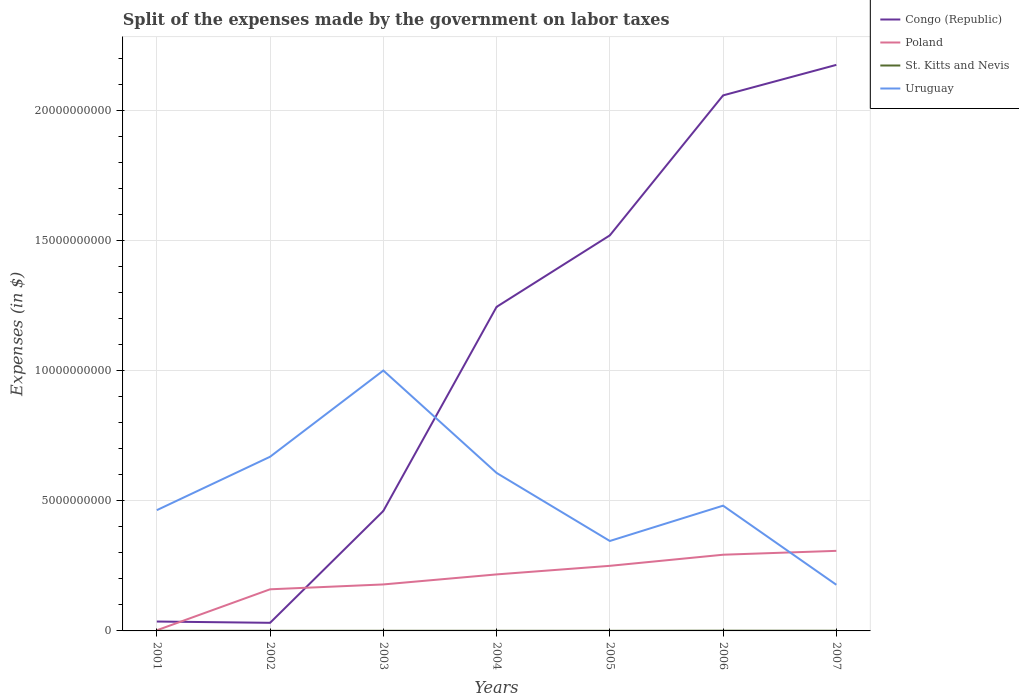How many different coloured lines are there?
Ensure brevity in your answer.  4. Does the line corresponding to Congo (Republic) intersect with the line corresponding to Uruguay?
Your response must be concise. Yes. Is the number of lines equal to the number of legend labels?
Offer a very short reply. Yes. Across all years, what is the maximum expenses made by the government on labor taxes in Congo (Republic)?
Your response must be concise. 3.12e+08. What is the total expenses made by the government on labor taxes in Poland in the graph?
Your response must be concise. -9.06e+08. What is the difference between the highest and the second highest expenses made by the government on labor taxes in Poland?
Ensure brevity in your answer.  3.06e+09. How many lines are there?
Keep it short and to the point. 4. How many years are there in the graph?
Provide a succinct answer. 7. Where does the legend appear in the graph?
Offer a very short reply. Top right. What is the title of the graph?
Your answer should be very brief. Split of the expenses made by the government on labor taxes. What is the label or title of the Y-axis?
Offer a terse response. Expenses (in $). What is the Expenses (in $) of Congo (Republic) in 2001?
Provide a short and direct response. 3.61e+08. What is the Expenses (in $) in Poland in 2001?
Make the answer very short. 2.50e+07. What is the Expenses (in $) in St. Kitts and Nevis in 2001?
Offer a very short reply. 4.40e+06. What is the Expenses (in $) of Uruguay in 2001?
Your answer should be compact. 4.65e+09. What is the Expenses (in $) of Congo (Republic) in 2002?
Give a very brief answer. 3.12e+08. What is the Expenses (in $) of Poland in 2002?
Ensure brevity in your answer.  1.60e+09. What is the Expenses (in $) in St. Kitts and Nevis in 2002?
Provide a succinct answer. 4.50e+06. What is the Expenses (in $) in Uruguay in 2002?
Your answer should be compact. 6.70e+09. What is the Expenses (in $) of Congo (Republic) in 2003?
Give a very brief answer. 4.61e+09. What is the Expenses (in $) in Poland in 2003?
Provide a succinct answer. 1.79e+09. What is the Expenses (in $) in St. Kitts and Nevis in 2003?
Give a very brief answer. 5.20e+06. What is the Expenses (in $) of Uruguay in 2003?
Provide a succinct answer. 1.00e+1. What is the Expenses (in $) of Congo (Republic) in 2004?
Your answer should be very brief. 1.25e+1. What is the Expenses (in $) in Poland in 2004?
Your answer should be compact. 2.17e+09. What is the Expenses (in $) of St. Kitts and Nevis in 2004?
Give a very brief answer. 5.10e+06. What is the Expenses (in $) of Uruguay in 2004?
Provide a short and direct response. 6.08e+09. What is the Expenses (in $) of Congo (Republic) in 2005?
Your answer should be compact. 1.52e+1. What is the Expenses (in $) of Poland in 2005?
Make the answer very short. 2.50e+09. What is the Expenses (in $) of Uruguay in 2005?
Keep it short and to the point. 3.46e+09. What is the Expenses (in $) in Congo (Republic) in 2006?
Give a very brief answer. 2.06e+1. What is the Expenses (in $) in Poland in 2006?
Keep it short and to the point. 2.93e+09. What is the Expenses (in $) in St. Kitts and Nevis in 2006?
Your answer should be compact. 8.70e+06. What is the Expenses (in $) in Uruguay in 2006?
Offer a terse response. 4.82e+09. What is the Expenses (in $) of Congo (Republic) in 2007?
Offer a terse response. 2.18e+1. What is the Expenses (in $) in Poland in 2007?
Provide a succinct answer. 3.08e+09. What is the Expenses (in $) of St. Kitts and Nevis in 2007?
Give a very brief answer. 7.40e+06. What is the Expenses (in $) in Uruguay in 2007?
Your answer should be very brief. 1.77e+09. Across all years, what is the maximum Expenses (in $) in Congo (Republic)?
Your answer should be compact. 2.18e+1. Across all years, what is the maximum Expenses (in $) of Poland?
Give a very brief answer. 3.08e+09. Across all years, what is the maximum Expenses (in $) of St. Kitts and Nevis?
Your answer should be very brief. 8.70e+06. Across all years, what is the maximum Expenses (in $) in Uruguay?
Your answer should be compact. 1.00e+1. Across all years, what is the minimum Expenses (in $) of Congo (Republic)?
Your answer should be very brief. 3.12e+08. Across all years, what is the minimum Expenses (in $) of Poland?
Ensure brevity in your answer.  2.50e+07. Across all years, what is the minimum Expenses (in $) in St. Kitts and Nevis?
Your response must be concise. 4.40e+06. Across all years, what is the minimum Expenses (in $) in Uruguay?
Offer a very short reply. 1.77e+09. What is the total Expenses (in $) in Congo (Republic) in the graph?
Your answer should be very brief. 7.53e+1. What is the total Expenses (in $) of Poland in the graph?
Make the answer very short. 1.41e+1. What is the total Expenses (in $) of St. Kitts and Nevis in the graph?
Keep it short and to the point. 4.03e+07. What is the total Expenses (in $) of Uruguay in the graph?
Ensure brevity in your answer.  3.75e+1. What is the difference between the Expenses (in $) in Congo (Republic) in 2001 and that in 2002?
Give a very brief answer. 4.94e+07. What is the difference between the Expenses (in $) of Poland in 2001 and that in 2002?
Provide a succinct answer. -1.58e+09. What is the difference between the Expenses (in $) of Uruguay in 2001 and that in 2002?
Your answer should be compact. -2.05e+09. What is the difference between the Expenses (in $) of Congo (Republic) in 2001 and that in 2003?
Offer a very short reply. -4.25e+09. What is the difference between the Expenses (in $) in Poland in 2001 and that in 2003?
Keep it short and to the point. -1.76e+09. What is the difference between the Expenses (in $) of St. Kitts and Nevis in 2001 and that in 2003?
Your answer should be very brief. -8.00e+05. What is the difference between the Expenses (in $) of Uruguay in 2001 and that in 2003?
Give a very brief answer. -5.37e+09. What is the difference between the Expenses (in $) in Congo (Republic) in 2001 and that in 2004?
Keep it short and to the point. -1.21e+1. What is the difference between the Expenses (in $) of Poland in 2001 and that in 2004?
Your response must be concise. -2.15e+09. What is the difference between the Expenses (in $) in St. Kitts and Nevis in 2001 and that in 2004?
Provide a short and direct response. -7.00e+05. What is the difference between the Expenses (in $) of Uruguay in 2001 and that in 2004?
Offer a very short reply. -1.43e+09. What is the difference between the Expenses (in $) in Congo (Republic) in 2001 and that in 2005?
Offer a terse response. -1.49e+1. What is the difference between the Expenses (in $) in Poland in 2001 and that in 2005?
Offer a terse response. -2.48e+09. What is the difference between the Expenses (in $) in St. Kitts and Nevis in 2001 and that in 2005?
Offer a very short reply. -6.00e+05. What is the difference between the Expenses (in $) of Uruguay in 2001 and that in 2005?
Ensure brevity in your answer.  1.19e+09. What is the difference between the Expenses (in $) in Congo (Republic) in 2001 and that in 2006?
Keep it short and to the point. -2.02e+1. What is the difference between the Expenses (in $) in Poland in 2001 and that in 2006?
Offer a very short reply. -2.91e+09. What is the difference between the Expenses (in $) of St. Kitts and Nevis in 2001 and that in 2006?
Your answer should be very brief. -4.30e+06. What is the difference between the Expenses (in $) in Uruguay in 2001 and that in 2006?
Your answer should be very brief. -1.73e+08. What is the difference between the Expenses (in $) in Congo (Republic) in 2001 and that in 2007?
Provide a short and direct response. -2.14e+1. What is the difference between the Expenses (in $) in Poland in 2001 and that in 2007?
Keep it short and to the point. -3.06e+09. What is the difference between the Expenses (in $) in Uruguay in 2001 and that in 2007?
Offer a very short reply. 2.87e+09. What is the difference between the Expenses (in $) in Congo (Republic) in 2002 and that in 2003?
Keep it short and to the point. -4.30e+09. What is the difference between the Expenses (in $) in Poland in 2002 and that in 2003?
Keep it short and to the point. -1.87e+08. What is the difference between the Expenses (in $) in St. Kitts and Nevis in 2002 and that in 2003?
Your answer should be compact. -7.00e+05. What is the difference between the Expenses (in $) of Uruguay in 2002 and that in 2003?
Your response must be concise. -3.32e+09. What is the difference between the Expenses (in $) in Congo (Republic) in 2002 and that in 2004?
Your answer should be compact. -1.22e+1. What is the difference between the Expenses (in $) of Poland in 2002 and that in 2004?
Provide a short and direct response. -5.73e+08. What is the difference between the Expenses (in $) of St. Kitts and Nevis in 2002 and that in 2004?
Your answer should be compact. -6.00e+05. What is the difference between the Expenses (in $) in Uruguay in 2002 and that in 2004?
Provide a short and direct response. 6.23e+08. What is the difference between the Expenses (in $) in Congo (Republic) in 2002 and that in 2005?
Your response must be concise. -1.49e+1. What is the difference between the Expenses (in $) of Poland in 2002 and that in 2005?
Offer a very short reply. -9.03e+08. What is the difference between the Expenses (in $) in St. Kitts and Nevis in 2002 and that in 2005?
Keep it short and to the point. -5.00e+05. What is the difference between the Expenses (in $) of Uruguay in 2002 and that in 2005?
Offer a very short reply. 3.24e+09. What is the difference between the Expenses (in $) of Congo (Republic) in 2002 and that in 2006?
Ensure brevity in your answer.  -2.03e+1. What is the difference between the Expenses (in $) in Poland in 2002 and that in 2006?
Your answer should be very brief. -1.33e+09. What is the difference between the Expenses (in $) of St. Kitts and Nevis in 2002 and that in 2006?
Provide a short and direct response. -4.20e+06. What is the difference between the Expenses (in $) of Uruguay in 2002 and that in 2006?
Give a very brief answer. 1.88e+09. What is the difference between the Expenses (in $) in Congo (Republic) in 2002 and that in 2007?
Ensure brevity in your answer.  -2.15e+1. What is the difference between the Expenses (in $) in Poland in 2002 and that in 2007?
Ensure brevity in your answer.  -1.48e+09. What is the difference between the Expenses (in $) in St. Kitts and Nevis in 2002 and that in 2007?
Your answer should be compact. -2.90e+06. What is the difference between the Expenses (in $) of Uruguay in 2002 and that in 2007?
Provide a succinct answer. 4.92e+09. What is the difference between the Expenses (in $) of Congo (Republic) in 2003 and that in 2004?
Ensure brevity in your answer.  -7.85e+09. What is the difference between the Expenses (in $) of Poland in 2003 and that in 2004?
Your answer should be very brief. -3.86e+08. What is the difference between the Expenses (in $) in St. Kitts and Nevis in 2003 and that in 2004?
Your response must be concise. 1.00e+05. What is the difference between the Expenses (in $) of Uruguay in 2003 and that in 2004?
Your answer should be compact. 3.94e+09. What is the difference between the Expenses (in $) in Congo (Republic) in 2003 and that in 2005?
Make the answer very short. -1.06e+1. What is the difference between the Expenses (in $) of Poland in 2003 and that in 2005?
Your answer should be very brief. -7.16e+08. What is the difference between the Expenses (in $) in Uruguay in 2003 and that in 2005?
Ensure brevity in your answer.  6.56e+09. What is the difference between the Expenses (in $) in Congo (Republic) in 2003 and that in 2006?
Your answer should be compact. -1.60e+1. What is the difference between the Expenses (in $) in Poland in 2003 and that in 2006?
Make the answer very short. -1.14e+09. What is the difference between the Expenses (in $) in St. Kitts and Nevis in 2003 and that in 2006?
Provide a short and direct response. -3.50e+06. What is the difference between the Expenses (in $) in Uruguay in 2003 and that in 2006?
Offer a very short reply. 5.20e+09. What is the difference between the Expenses (in $) of Congo (Republic) in 2003 and that in 2007?
Your answer should be compact. -1.72e+1. What is the difference between the Expenses (in $) in Poland in 2003 and that in 2007?
Offer a terse response. -1.29e+09. What is the difference between the Expenses (in $) of St. Kitts and Nevis in 2003 and that in 2007?
Provide a short and direct response. -2.20e+06. What is the difference between the Expenses (in $) of Uruguay in 2003 and that in 2007?
Keep it short and to the point. 8.24e+09. What is the difference between the Expenses (in $) of Congo (Republic) in 2004 and that in 2005?
Offer a very short reply. -2.75e+09. What is the difference between the Expenses (in $) in Poland in 2004 and that in 2005?
Offer a very short reply. -3.30e+08. What is the difference between the Expenses (in $) of St. Kitts and Nevis in 2004 and that in 2005?
Provide a short and direct response. 1.00e+05. What is the difference between the Expenses (in $) in Uruguay in 2004 and that in 2005?
Offer a very short reply. 2.62e+09. What is the difference between the Expenses (in $) of Congo (Republic) in 2004 and that in 2006?
Give a very brief answer. -8.14e+09. What is the difference between the Expenses (in $) in Poland in 2004 and that in 2006?
Give a very brief answer. -7.57e+08. What is the difference between the Expenses (in $) in St. Kitts and Nevis in 2004 and that in 2006?
Give a very brief answer. -3.60e+06. What is the difference between the Expenses (in $) of Uruguay in 2004 and that in 2006?
Your answer should be very brief. 1.26e+09. What is the difference between the Expenses (in $) of Congo (Republic) in 2004 and that in 2007?
Your answer should be compact. -9.31e+09. What is the difference between the Expenses (in $) in Poland in 2004 and that in 2007?
Offer a terse response. -9.06e+08. What is the difference between the Expenses (in $) of St. Kitts and Nevis in 2004 and that in 2007?
Keep it short and to the point. -2.30e+06. What is the difference between the Expenses (in $) of Uruguay in 2004 and that in 2007?
Your answer should be compact. 4.30e+09. What is the difference between the Expenses (in $) in Congo (Republic) in 2005 and that in 2006?
Provide a short and direct response. -5.38e+09. What is the difference between the Expenses (in $) of Poland in 2005 and that in 2006?
Offer a terse response. -4.27e+08. What is the difference between the Expenses (in $) of St. Kitts and Nevis in 2005 and that in 2006?
Your answer should be compact. -3.70e+06. What is the difference between the Expenses (in $) in Uruguay in 2005 and that in 2006?
Offer a terse response. -1.36e+09. What is the difference between the Expenses (in $) in Congo (Republic) in 2005 and that in 2007?
Provide a succinct answer. -6.56e+09. What is the difference between the Expenses (in $) in Poland in 2005 and that in 2007?
Ensure brevity in your answer.  -5.76e+08. What is the difference between the Expenses (in $) of St. Kitts and Nevis in 2005 and that in 2007?
Keep it short and to the point. -2.40e+06. What is the difference between the Expenses (in $) in Uruguay in 2005 and that in 2007?
Your response must be concise. 1.68e+09. What is the difference between the Expenses (in $) of Congo (Republic) in 2006 and that in 2007?
Keep it short and to the point. -1.17e+09. What is the difference between the Expenses (in $) in Poland in 2006 and that in 2007?
Give a very brief answer. -1.49e+08. What is the difference between the Expenses (in $) in St. Kitts and Nevis in 2006 and that in 2007?
Your answer should be compact. 1.30e+06. What is the difference between the Expenses (in $) in Uruguay in 2006 and that in 2007?
Your response must be concise. 3.04e+09. What is the difference between the Expenses (in $) of Congo (Republic) in 2001 and the Expenses (in $) of Poland in 2002?
Give a very brief answer. -1.24e+09. What is the difference between the Expenses (in $) in Congo (Republic) in 2001 and the Expenses (in $) in St. Kitts and Nevis in 2002?
Provide a succinct answer. 3.57e+08. What is the difference between the Expenses (in $) in Congo (Republic) in 2001 and the Expenses (in $) in Uruguay in 2002?
Your answer should be compact. -6.34e+09. What is the difference between the Expenses (in $) in Poland in 2001 and the Expenses (in $) in St. Kitts and Nevis in 2002?
Your response must be concise. 2.05e+07. What is the difference between the Expenses (in $) of Poland in 2001 and the Expenses (in $) of Uruguay in 2002?
Give a very brief answer. -6.67e+09. What is the difference between the Expenses (in $) of St. Kitts and Nevis in 2001 and the Expenses (in $) of Uruguay in 2002?
Make the answer very short. -6.70e+09. What is the difference between the Expenses (in $) of Congo (Republic) in 2001 and the Expenses (in $) of Poland in 2003?
Provide a succinct answer. -1.43e+09. What is the difference between the Expenses (in $) in Congo (Republic) in 2001 and the Expenses (in $) in St. Kitts and Nevis in 2003?
Your response must be concise. 3.56e+08. What is the difference between the Expenses (in $) of Congo (Republic) in 2001 and the Expenses (in $) of Uruguay in 2003?
Offer a terse response. -9.66e+09. What is the difference between the Expenses (in $) in Poland in 2001 and the Expenses (in $) in St. Kitts and Nevis in 2003?
Ensure brevity in your answer.  1.98e+07. What is the difference between the Expenses (in $) in Poland in 2001 and the Expenses (in $) in Uruguay in 2003?
Keep it short and to the point. -9.99e+09. What is the difference between the Expenses (in $) in St. Kitts and Nevis in 2001 and the Expenses (in $) in Uruguay in 2003?
Your answer should be compact. -1.00e+1. What is the difference between the Expenses (in $) in Congo (Republic) in 2001 and the Expenses (in $) in Poland in 2004?
Provide a short and direct response. -1.81e+09. What is the difference between the Expenses (in $) in Congo (Republic) in 2001 and the Expenses (in $) in St. Kitts and Nevis in 2004?
Your answer should be very brief. 3.56e+08. What is the difference between the Expenses (in $) of Congo (Republic) in 2001 and the Expenses (in $) of Uruguay in 2004?
Keep it short and to the point. -5.72e+09. What is the difference between the Expenses (in $) of Poland in 2001 and the Expenses (in $) of St. Kitts and Nevis in 2004?
Keep it short and to the point. 1.99e+07. What is the difference between the Expenses (in $) in Poland in 2001 and the Expenses (in $) in Uruguay in 2004?
Provide a succinct answer. -6.05e+09. What is the difference between the Expenses (in $) of St. Kitts and Nevis in 2001 and the Expenses (in $) of Uruguay in 2004?
Offer a very short reply. -6.07e+09. What is the difference between the Expenses (in $) in Congo (Republic) in 2001 and the Expenses (in $) in Poland in 2005?
Ensure brevity in your answer.  -2.14e+09. What is the difference between the Expenses (in $) of Congo (Republic) in 2001 and the Expenses (in $) of St. Kitts and Nevis in 2005?
Give a very brief answer. 3.56e+08. What is the difference between the Expenses (in $) in Congo (Republic) in 2001 and the Expenses (in $) in Uruguay in 2005?
Make the answer very short. -3.10e+09. What is the difference between the Expenses (in $) of Poland in 2001 and the Expenses (in $) of Uruguay in 2005?
Your answer should be compact. -3.43e+09. What is the difference between the Expenses (in $) of St. Kitts and Nevis in 2001 and the Expenses (in $) of Uruguay in 2005?
Provide a succinct answer. -3.45e+09. What is the difference between the Expenses (in $) in Congo (Republic) in 2001 and the Expenses (in $) in Poland in 2006?
Offer a terse response. -2.57e+09. What is the difference between the Expenses (in $) in Congo (Republic) in 2001 and the Expenses (in $) in St. Kitts and Nevis in 2006?
Make the answer very short. 3.53e+08. What is the difference between the Expenses (in $) of Congo (Republic) in 2001 and the Expenses (in $) of Uruguay in 2006?
Offer a very short reply. -4.46e+09. What is the difference between the Expenses (in $) of Poland in 2001 and the Expenses (in $) of St. Kitts and Nevis in 2006?
Your response must be concise. 1.63e+07. What is the difference between the Expenses (in $) of Poland in 2001 and the Expenses (in $) of Uruguay in 2006?
Your answer should be very brief. -4.79e+09. What is the difference between the Expenses (in $) in St. Kitts and Nevis in 2001 and the Expenses (in $) in Uruguay in 2006?
Keep it short and to the point. -4.81e+09. What is the difference between the Expenses (in $) in Congo (Republic) in 2001 and the Expenses (in $) in Poland in 2007?
Your answer should be compact. -2.72e+09. What is the difference between the Expenses (in $) of Congo (Republic) in 2001 and the Expenses (in $) of St. Kitts and Nevis in 2007?
Offer a very short reply. 3.54e+08. What is the difference between the Expenses (in $) in Congo (Republic) in 2001 and the Expenses (in $) in Uruguay in 2007?
Offer a terse response. -1.41e+09. What is the difference between the Expenses (in $) in Poland in 2001 and the Expenses (in $) in St. Kitts and Nevis in 2007?
Your answer should be very brief. 1.76e+07. What is the difference between the Expenses (in $) of Poland in 2001 and the Expenses (in $) of Uruguay in 2007?
Offer a very short reply. -1.75e+09. What is the difference between the Expenses (in $) in St. Kitts and Nevis in 2001 and the Expenses (in $) in Uruguay in 2007?
Provide a short and direct response. -1.77e+09. What is the difference between the Expenses (in $) of Congo (Republic) in 2002 and the Expenses (in $) of Poland in 2003?
Your answer should be compact. -1.48e+09. What is the difference between the Expenses (in $) of Congo (Republic) in 2002 and the Expenses (in $) of St. Kitts and Nevis in 2003?
Make the answer very short. 3.07e+08. What is the difference between the Expenses (in $) in Congo (Republic) in 2002 and the Expenses (in $) in Uruguay in 2003?
Your answer should be compact. -9.71e+09. What is the difference between the Expenses (in $) of Poland in 2002 and the Expenses (in $) of St. Kitts and Nevis in 2003?
Provide a short and direct response. 1.60e+09. What is the difference between the Expenses (in $) in Poland in 2002 and the Expenses (in $) in Uruguay in 2003?
Your response must be concise. -8.42e+09. What is the difference between the Expenses (in $) in St. Kitts and Nevis in 2002 and the Expenses (in $) in Uruguay in 2003?
Provide a short and direct response. -1.00e+1. What is the difference between the Expenses (in $) in Congo (Republic) in 2002 and the Expenses (in $) in Poland in 2004?
Provide a short and direct response. -1.86e+09. What is the difference between the Expenses (in $) in Congo (Republic) in 2002 and the Expenses (in $) in St. Kitts and Nevis in 2004?
Keep it short and to the point. 3.07e+08. What is the difference between the Expenses (in $) in Congo (Republic) in 2002 and the Expenses (in $) in Uruguay in 2004?
Your response must be concise. -5.77e+09. What is the difference between the Expenses (in $) of Poland in 2002 and the Expenses (in $) of St. Kitts and Nevis in 2004?
Offer a very short reply. 1.60e+09. What is the difference between the Expenses (in $) in Poland in 2002 and the Expenses (in $) in Uruguay in 2004?
Give a very brief answer. -4.48e+09. What is the difference between the Expenses (in $) in St. Kitts and Nevis in 2002 and the Expenses (in $) in Uruguay in 2004?
Your answer should be compact. -6.07e+09. What is the difference between the Expenses (in $) in Congo (Republic) in 2002 and the Expenses (in $) in Poland in 2005?
Your answer should be very brief. -2.19e+09. What is the difference between the Expenses (in $) of Congo (Republic) in 2002 and the Expenses (in $) of St. Kitts and Nevis in 2005?
Your answer should be very brief. 3.07e+08. What is the difference between the Expenses (in $) in Congo (Republic) in 2002 and the Expenses (in $) in Uruguay in 2005?
Provide a succinct answer. -3.15e+09. What is the difference between the Expenses (in $) in Poland in 2002 and the Expenses (in $) in St. Kitts and Nevis in 2005?
Keep it short and to the point. 1.60e+09. What is the difference between the Expenses (in $) of Poland in 2002 and the Expenses (in $) of Uruguay in 2005?
Provide a short and direct response. -1.86e+09. What is the difference between the Expenses (in $) in St. Kitts and Nevis in 2002 and the Expenses (in $) in Uruguay in 2005?
Your answer should be very brief. -3.45e+09. What is the difference between the Expenses (in $) in Congo (Republic) in 2002 and the Expenses (in $) in Poland in 2006?
Ensure brevity in your answer.  -2.62e+09. What is the difference between the Expenses (in $) in Congo (Republic) in 2002 and the Expenses (in $) in St. Kitts and Nevis in 2006?
Ensure brevity in your answer.  3.03e+08. What is the difference between the Expenses (in $) of Congo (Republic) in 2002 and the Expenses (in $) of Uruguay in 2006?
Your answer should be compact. -4.51e+09. What is the difference between the Expenses (in $) in Poland in 2002 and the Expenses (in $) in St. Kitts and Nevis in 2006?
Your answer should be compact. 1.59e+09. What is the difference between the Expenses (in $) in Poland in 2002 and the Expenses (in $) in Uruguay in 2006?
Your response must be concise. -3.22e+09. What is the difference between the Expenses (in $) of St. Kitts and Nevis in 2002 and the Expenses (in $) of Uruguay in 2006?
Offer a very short reply. -4.81e+09. What is the difference between the Expenses (in $) of Congo (Republic) in 2002 and the Expenses (in $) of Poland in 2007?
Your answer should be compact. -2.77e+09. What is the difference between the Expenses (in $) in Congo (Republic) in 2002 and the Expenses (in $) in St. Kitts and Nevis in 2007?
Keep it short and to the point. 3.04e+08. What is the difference between the Expenses (in $) in Congo (Republic) in 2002 and the Expenses (in $) in Uruguay in 2007?
Offer a terse response. -1.46e+09. What is the difference between the Expenses (in $) in Poland in 2002 and the Expenses (in $) in St. Kitts and Nevis in 2007?
Provide a short and direct response. 1.59e+09. What is the difference between the Expenses (in $) of Poland in 2002 and the Expenses (in $) of Uruguay in 2007?
Provide a short and direct response. -1.74e+08. What is the difference between the Expenses (in $) of St. Kitts and Nevis in 2002 and the Expenses (in $) of Uruguay in 2007?
Keep it short and to the point. -1.77e+09. What is the difference between the Expenses (in $) in Congo (Republic) in 2003 and the Expenses (in $) in Poland in 2004?
Your response must be concise. 2.44e+09. What is the difference between the Expenses (in $) of Congo (Republic) in 2003 and the Expenses (in $) of St. Kitts and Nevis in 2004?
Ensure brevity in your answer.  4.61e+09. What is the difference between the Expenses (in $) in Congo (Republic) in 2003 and the Expenses (in $) in Uruguay in 2004?
Provide a succinct answer. -1.46e+09. What is the difference between the Expenses (in $) of Poland in 2003 and the Expenses (in $) of St. Kitts and Nevis in 2004?
Keep it short and to the point. 1.78e+09. What is the difference between the Expenses (in $) of Poland in 2003 and the Expenses (in $) of Uruguay in 2004?
Your answer should be compact. -4.29e+09. What is the difference between the Expenses (in $) of St. Kitts and Nevis in 2003 and the Expenses (in $) of Uruguay in 2004?
Give a very brief answer. -6.07e+09. What is the difference between the Expenses (in $) in Congo (Republic) in 2003 and the Expenses (in $) in Poland in 2005?
Your response must be concise. 2.11e+09. What is the difference between the Expenses (in $) in Congo (Republic) in 2003 and the Expenses (in $) in St. Kitts and Nevis in 2005?
Your answer should be compact. 4.61e+09. What is the difference between the Expenses (in $) in Congo (Republic) in 2003 and the Expenses (in $) in Uruguay in 2005?
Ensure brevity in your answer.  1.16e+09. What is the difference between the Expenses (in $) of Poland in 2003 and the Expenses (in $) of St. Kitts and Nevis in 2005?
Your answer should be very brief. 1.78e+09. What is the difference between the Expenses (in $) of Poland in 2003 and the Expenses (in $) of Uruguay in 2005?
Provide a short and direct response. -1.67e+09. What is the difference between the Expenses (in $) in St. Kitts and Nevis in 2003 and the Expenses (in $) in Uruguay in 2005?
Keep it short and to the point. -3.45e+09. What is the difference between the Expenses (in $) in Congo (Republic) in 2003 and the Expenses (in $) in Poland in 2006?
Make the answer very short. 1.68e+09. What is the difference between the Expenses (in $) in Congo (Republic) in 2003 and the Expenses (in $) in St. Kitts and Nevis in 2006?
Provide a succinct answer. 4.61e+09. What is the difference between the Expenses (in $) in Congo (Republic) in 2003 and the Expenses (in $) in Uruguay in 2006?
Keep it short and to the point. -2.04e+08. What is the difference between the Expenses (in $) in Poland in 2003 and the Expenses (in $) in St. Kitts and Nevis in 2006?
Ensure brevity in your answer.  1.78e+09. What is the difference between the Expenses (in $) in Poland in 2003 and the Expenses (in $) in Uruguay in 2006?
Provide a succinct answer. -3.03e+09. What is the difference between the Expenses (in $) in St. Kitts and Nevis in 2003 and the Expenses (in $) in Uruguay in 2006?
Provide a short and direct response. -4.81e+09. What is the difference between the Expenses (in $) in Congo (Republic) in 2003 and the Expenses (in $) in Poland in 2007?
Offer a terse response. 1.53e+09. What is the difference between the Expenses (in $) of Congo (Republic) in 2003 and the Expenses (in $) of St. Kitts and Nevis in 2007?
Your answer should be compact. 4.61e+09. What is the difference between the Expenses (in $) in Congo (Republic) in 2003 and the Expenses (in $) in Uruguay in 2007?
Your answer should be very brief. 2.84e+09. What is the difference between the Expenses (in $) of Poland in 2003 and the Expenses (in $) of St. Kitts and Nevis in 2007?
Offer a very short reply. 1.78e+09. What is the difference between the Expenses (in $) of Poland in 2003 and the Expenses (in $) of Uruguay in 2007?
Keep it short and to the point. 1.31e+07. What is the difference between the Expenses (in $) in St. Kitts and Nevis in 2003 and the Expenses (in $) in Uruguay in 2007?
Give a very brief answer. -1.77e+09. What is the difference between the Expenses (in $) of Congo (Republic) in 2004 and the Expenses (in $) of Poland in 2005?
Make the answer very short. 9.96e+09. What is the difference between the Expenses (in $) in Congo (Republic) in 2004 and the Expenses (in $) in St. Kitts and Nevis in 2005?
Your response must be concise. 1.25e+1. What is the difference between the Expenses (in $) of Congo (Republic) in 2004 and the Expenses (in $) of Uruguay in 2005?
Offer a terse response. 9.01e+09. What is the difference between the Expenses (in $) in Poland in 2004 and the Expenses (in $) in St. Kitts and Nevis in 2005?
Your response must be concise. 2.17e+09. What is the difference between the Expenses (in $) in Poland in 2004 and the Expenses (in $) in Uruguay in 2005?
Provide a succinct answer. -1.29e+09. What is the difference between the Expenses (in $) in St. Kitts and Nevis in 2004 and the Expenses (in $) in Uruguay in 2005?
Ensure brevity in your answer.  -3.45e+09. What is the difference between the Expenses (in $) in Congo (Republic) in 2004 and the Expenses (in $) in Poland in 2006?
Make the answer very short. 9.53e+09. What is the difference between the Expenses (in $) in Congo (Republic) in 2004 and the Expenses (in $) in St. Kitts and Nevis in 2006?
Provide a succinct answer. 1.25e+1. What is the difference between the Expenses (in $) in Congo (Republic) in 2004 and the Expenses (in $) in Uruguay in 2006?
Provide a short and direct response. 7.65e+09. What is the difference between the Expenses (in $) of Poland in 2004 and the Expenses (in $) of St. Kitts and Nevis in 2006?
Your response must be concise. 2.17e+09. What is the difference between the Expenses (in $) of Poland in 2004 and the Expenses (in $) of Uruguay in 2006?
Offer a terse response. -2.64e+09. What is the difference between the Expenses (in $) in St. Kitts and Nevis in 2004 and the Expenses (in $) in Uruguay in 2006?
Your answer should be very brief. -4.81e+09. What is the difference between the Expenses (in $) of Congo (Republic) in 2004 and the Expenses (in $) of Poland in 2007?
Your response must be concise. 9.38e+09. What is the difference between the Expenses (in $) in Congo (Republic) in 2004 and the Expenses (in $) in St. Kitts and Nevis in 2007?
Keep it short and to the point. 1.25e+1. What is the difference between the Expenses (in $) of Congo (Republic) in 2004 and the Expenses (in $) of Uruguay in 2007?
Offer a terse response. 1.07e+1. What is the difference between the Expenses (in $) of Poland in 2004 and the Expenses (in $) of St. Kitts and Nevis in 2007?
Provide a succinct answer. 2.17e+09. What is the difference between the Expenses (in $) of Poland in 2004 and the Expenses (in $) of Uruguay in 2007?
Make the answer very short. 3.99e+08. What is the difference between the Expenses (in $) in St. Kitts and Nevis in 2004 and the Expenses (in $) in Uruguay in 2007?
Make the answer very short. -1.77e+09. What is the difference between the Expenses (in $) in Congo (Republic) in 2005 and the Expenses (in $) in Poland in 2006?
Your answer should be compact. 1.23e+1. What is the difference between the Expenses (in $) in Congo (Republic) in 2005 and the Expenses (in $) in St. Kitts and Nevis in 2006?
Your answer should be very brief. 1.52e+1. What is the difference between the Expenses (in $) of Congo (Republic) in 2005 and the Expenses (in $) of Uruguay in 2006?
Keep it short and to the point. 1.04e+1. What is the difference between the Expenses (in $) in Poland in 2005 and the Expenses (in $) in St. Kitts and Nevis in 2006?
Your answer should be very brief. 2.50e+09. What is the difference between the Expenses (in $) in Poland in 2005 and the Expenses (in $) in Uruguay in 2006?
Your answer should be very brief. -2.31e+09. What is the difference between the Expenses (in $) of St. Kitts and Nevis in 2005 and the Expenses (in $) of Uruguay in 2006?
Give a very brief answer. -4.81e+09. What is the difference between the Expenses (in $) in Congo (Republic) in 2005 and the Expenses (in $) in Poland in 2007?
Offer a very short reply. 1.21e+1. What is the difference between the Expenses (in $) of Congo (Republic) in 2005 and the Expenses (in $) of St. Kitts and Nevis in 2007?
Offer a terse response. 1.52e+1. What is the difference between the Expenses (in $) of Congo (Republic) in 2005 and the Expenses (in $) of Uruguay in 2007?
Your response must be concise. 1.34e+1. What is the difference between the Expenses (in $) in Poland in 2005 and the Expenses (in $) in St. Kitts and Nevis in 2007?
Your answer should be compact. 2.50e+09. What is the difference between the Expenses (in $) of Poland in 2005 and the Expenses (in $) of Uruguay in 2007?
Provide a succinct answer. 7.29e+08. What is the difference between the Expenses (in $) of St. Kitts and Nevis in 2005 and the Expenses (in $) of Uruguay in 2007?
Keep it short and to the point. -1.77e+09. What is the difference between the Expenses (in $) in Congo (Republic) in 2006 and the Expenses (in $) in Poland in 2007?
Provide a short and direct response. 1.75e+1. What is the difference between the Expenses (in $) of Congo (Republic) in 2006 and the Expenses (in $) of St. Kitts and Nevis in 2007?
Provide a succinct answer. 2.06e+1. What is the difference between the Expenses (in $) in Congo (Republic) in 2006 and the Expenses (in $) in Uruguay in 2007?
Your answer should be compact. 1.88e+1. What is the difference between the Expenses (in $) of Poland in 2006 and the Expenses (in $) of St. Kitts and Nevis in 2007?
Offer a terse response. 2.92e+09. What is the difference between the Expenses (in $) of Poland in 2006 and the Expenses (in $) of Uruguay in 2007?
Ensure brevity in your answer.  1.16e+09. What is the difference between the Expenses (in $) in St. Kitts and Nevis in 2006 and the Expenses (in $) in Uruguay in 2007?
Keep it short and to the point. -1.77e+09. What is the average Expenses (in $) in Congo (Republic) per year?
Your response must be concise. 1.08e+1. What is the average Expenses (in $) of Poland per year?
Give a very brief answer. 2.01e+09. What is the average Expenses (in $) of St. Kitts and Nevis per year?
Offer a very short reply. 5.76e+06. What is the average Expenses (in $) of Uruguay per year?
Give a very brief answer. 5.36e+09. In the year 2001, what is the difference between the Expenses (in $) of Congo (Republic) and Expenses (in $) of Poland?
Your answer should be very brief. 3.36e+08. In the year 2001, what is the difference between the Expenses (in $) of Congo (Republic) and Expenses (in $) of St. Kitts and Nevis?
Make the answer very short. 3.57e+08. In the year 2001, what is the difference between the Expenses (in $) of Congo (Republic) and Expenses (in $) of Uruguay?
Offer a very short reply. -4.28e+09. In the year 2001, what is the difference between the Expenses (in $) of Poland and Expenses (in $) of St. Kitts and Nevis?
Ensure brevity in your answer.  2.06e+07. In the year 2001, what is the difference between the Expenses (in $) in Poland and Expenses (in $) in Uruguay?
Give a very brief answer. -4.62e+09. In the year 2001, what is the difference between the Expenses (in $) of St. Kitts and Nevis and Expenses (in $) of Uruguay?
Your answer should be compact. -4.64e+09. In the year 2002, what is the difference between the Expenses (in $) in Congo (Republic) and Expenses (in $) in Poland?
Provide a succinct answer. -1.29e+09. In the year 2002, what is the difference between the Expenses (in $) in Congo (Republic) and Expenses (in $) in St. Kitts and Nevis?
Offer a terse response. 3.07e+08. In the year 2002, what is the difference between the Expenses (in $) in Congo (Republic) and Expenses (in $) in Uruguay?
Give a very brief answer. -6.39e+09. In the year 2002, what is the difference between the Expenses (in $) in Poland and Expenses (in $) in St. Kitts and Nevis?
Ensure brevity in your answer.  1.60e+09. In the year 2002, what is the difference between the Expenses (in $) in Poland and Expenses (in $) in Uruguay?
Make the answer very short. -5.10e+09. In the year 2002, what is the difference between the Expenses (in $) in St. Kitts and Nevis and Expenses (in $) in Uruguay?
Provide a succinct answer. -6.70e+09. In the year 2003, what is the difference between the Expenses (in $) of Congo (Republic) and Expenses (in $) of Poland?
Provide a succinct answer. 2.83e+09. In the year 2003, what is the difference between the Expenses (in $) in Congo (Republic) and Expenses (in $) in St. Kitts and Nevis?
Your answer should be compact. 4.61e+09. In the year 2003, what is the difference between the Expenses (in $) of Congo (Republic) and Expenses (in $) of Uruguay?
Your response must be concise. -5.40e+09. In the year 2003, what is the difference between the Expenses (in $) in Poland and Expenses (in $) in St. Kitts and Nevis?
Your response must be concise. 1.78e+09. In the year 2003, what is the difference between the Expenses (in $) in Poland and Expenses (in $) in Uruguay?
Provide a succinct answer. -8.23e+09. In the year 2003, what is the difference between the Expenses (in $) of St. Kitts and Nevis and Expenses (in $) of Uruguay?
Provide a succinct answer. -1.00e+1. In the year 2004, what is the difference between the Expenses (in $) of Congo (Republic) and Expenses (in $) of Poland?
Your answer should be compact. 1.03e+1. In the year 2004, what is the difference between the Expenses (in $) of Congo (Republic) and Expenses (in $) of St. Kitts and Nevis?
Provide a succinct answer. 1.25e+1. In the year 2004, what is the difference between the Expenses (in $) in Congo (Republic) and Expenses (in $) in Uruguay?
Provide a succinct answer. 6.39e+09. In the year 2004, what is the difference between the Expenses (in $) in Poland and Expenses (in $) in St. Kitts and Nevis?
Give a very brief answer. 2.17e+09. In the year 2004, what is the difference between the Expenses (in $) in Poland and Expenses (in $) in Uruguay?
Provide a succinct answer. -3.90e+09. In the year 2004, what is the difference between the Expenses (in $) of St. Kitts and Nevis and Expenses (in $) of Uruguay?
Your response must be concise. -6.07e+09. In the year 2005, what is the difference between the Expenses (in $) of Congo (Republic) and Expenses (in $) of Poland?
Provide a succinct answer. 1.27e+1. In the year 2005, what is the difference between the Expenses (in $) in Congo (Republic) and Expenses (in $) in St. Kitts and Nevis?
Give a very brief answer. 1.52e+1. In the year 2005, what is the difference between the Expenses (in $) of Congo (Republic) and Expenses (in $) of Uruguay?
Your answer should be very brief. 1.18e+1. In the year 2005, what is the difference between the Expenses (in $) of Poland and Expenses (in $) of St. Kitts and Nevis?
Give a very brief answer. 2.50e+09. In the year 2005, what is the difference between the Expenses (in $) of Poland and Expenses (in $) of Uruguay?
Keep it short and to the point. -9.55e+08. In the year 2005, what is the difference between the Expenses (in $) of St. Kitts and Nevis and Expenses (in $) of Uruguay?
Give a very brief answer. -3.45e+09. In the year 2006, what is the difference between the Expenses (in $) of Congo (Republic) and Expenses (in $) of Poland?
Ensure brevity in your answer.  1.77e+1. In the year 2006, what is the difference between the Expenses (in $) in Congo (Republic) and Expenses (in $) in St. Kitts and Nevis?
Provide a succinct answer. 2.06e+1. In the year 2006, what is the difference between the Expenses (in $) in Congo (Republic) and Expenses (in $) in Uruguay?
Provide a succinct answer. 1.58e+1. In the year 2006, what is the difference between the Expenses (in $) of Poland and Expenses (in $) of St. Kitts and Nevis?
Keep it short and to the point. 2.92e+09. In the year 2006, what is the difference between the Expenses (in $) in Poland and Expenses (in $) in Uruguay?
Provide a short and direct response. -1.89e+09. In the year 2006, what is the difference between the Expenses (in $) of St. Kitts and Nevis and Expenses (in $) of Uruguay?
Ensure brevity in your answer.  -4.81e+09. In the year 2007, what is the difference between the Expenses (in $) in Congo (Republic) and Expenses (in $) in Poland?
Your answer should be compact. 1.87e+1. In the year 2007, what is the difference between the Expenses (in $) of Congo (Republic) and Expenses (in $) of St. Kitts and Nevis?
Offer a terse response. 2.18e+1. In the year 2007, what is the difference between the Expenses (in $) in Congo (Republic) and Expenses (in $) in Uruguay?
Ensure brevity in your answer.  2.00e+1. In the year 2007, what is the difference between the Expenses (in $) of Poland and Expenses (in $) of St. Kitts and Nevis?
Give a very brief answer. 3.07e+09. In the year 2007, what is the difference between the Expenses (in $) in Poland and Expenses (in $) in Uruguay?
Your answer should be compact. 1.31e+09. In the year 2007, what is the difference between the Expenses (in $) in St. Kitts and Nevis and Expenses (in $) in Uruguay?
Keep it short and to the point. -1.77e+09. What is the ratio of the Expenses (in $) of Congo (Republic) in 2001 to that in 2002?
Keep it short and to the point. 1.16. What is the ratio of the Expenses (in $) of Poland in 2001 to that in 2002?
Keep it short and to the point. 0.02. What is the ratio of the Expenses (in $) in St. Kitts and Nevis in 2001 to that in 2002?
Give a very brief answer. 0.98. What is the ratio of the Expenses (in $) in Uruguay in 2001 to that in 2002?
Provide a short and direct response. 0.69. What is the ratio of the Expenses (in $) in Congo (Republic) in 2001 to that in 2003?
Your answer should be very brief. 0.08. What is the ratio of the Expenses (in $) in Poland in 2001 to that in 2003?
Provide a short and direct response. 0.01. What is the ratio of the Expenses (in $) of St. Kitts and Nevis in 2001 to that in 2003?
Provide a succinct answer. 0.85. What is the ratio of the Expenses (in $) in Uruguay in 2001 to that in 2003?
Provide a succinct answer. 0.46. What is the ratio of the Expenses (in $) in Congo (Republic) in 2001 to that in 2004?
Keep it short and to the point. 0.03. What is the ratio of the Expenses (in $) in Poland in 2001 to that in 2004?
Offer a very short reply. 0.01. What is the ratio of the Expenses (in $) of St. Kitts and Nevis in 2001 to that in 2004?
Ensure brevity in your answer.  0.86. What is the ratio of the Expenses (in $) in Uruguay in 2001 to that in 2004?
Keep it short and to the point. 0.76. What is the ratio of the Expenses (in $) of Congo (Republic) in 2001 to that in 2005?
Offer a very short reply. 0.02. What is the ratio of the Expenses (in $) in St. Kitts and Nevis in 2001 to that in 2005?
Make the answer very short. 0.88. What is the ratio of the Expenses (in $) of Uruguay in 2001 to that in 2005?
Your response must be concise. 1.34. What is the ratio of the Expenses (in $) of Congo (Republic) in 2001 to that in 2006?
Your response must be concise. 0.02. What is the ratio of the Expenses (in $) in Poland in 2001 to that in 2006?
Your response must be concise. 0.01. What is the ratio of the Expenses (in $) in St. Kitts and Nevis in 2001 to that in 2006?
Give a very brief answer. 0.51. What is the ratio of the Expenses (in $) of Uruguay in 2001 to that in 2006?
Offer a terse response. 0.96. What is the ratio of the Expenses (in $) in Congo (Republic) in 2001 to that in 2007?
Offer a terse response. 0.02. What is the ratio of the Expenses (in $) of Poland in 2001 to that in 2007?
Offer a very short reply. 0.01. What is the ratio of the Expenses (in $) of St. Kitts and Nevis in 2001 to that in 2007?
Give a very brief answer. 0.59. What is the ratio of the Expenses (in $) of Uruguay in 2001 to that in 2007?
Provide a succinct answer. 2.62. What is the ratio of the Expenses (in $) of Congo (Republic) in 2002 to that in 2003?
Provide a short and direct response. 0.07. What is the ratio of the Expenses (in $) of Poland in 2002 to that in 2003?
Your answer should be very brief. 0.9. What is the ratio of the Expenses (in $) in St. Kitts and Nevis in 2002 to that in 2003?
Offer a very short reply. 0.87. What is the ratio of the Expenses (in $) of Uruguay in 2002 to that in 2003?
Your answer should be compact. 0.67. What is the ratio of the Expenses (in $) in Congo (Republic) in 2002 to that in 2004?
Offer a terse response. 0.03. What is the ratio of the Expenses (in $) in Poland in 2002 to that in 2004?
Offer a very short reply. 0.74. What is the ratio of the Expenses (in $) in St. Kitts and Nevis in 2002 to that in 2004?
Keep it short and to the point. 0.88. What is the ratio of the Expenses (in $) of Uruguay in 2002 to that in 2004?
Ensure brevity in your answer.  1.1. What is the ratio of the Expenses (in $) in Congo (Republic) in 2002 to that in 2005?
Make the answer very short. 0.02. What is the ratio of the Expenses (in $) in Poland in 2002 to that in 2005?
Offer a very short reply. 0.64. What is the ratio of the Expenses (in $) in Uruguay in 2002 to that in 2005?
Offer a very short reply. 1.94. What is the ratio of the Expenses (in $) in Congo (Republic) in 2002 to that in 2006?
Your response must be concise. 0.02. What is the ratio of the Expenses (in $) in Poland in 2002 to that in 2006?
Your response must be concise. 0.55. What is the ratio of the Expenses (in $) of St. Kitts and Nevis in 2002 to that in 2006?
Ensure brevity in your answer.  0.52. What is the ratio of the Expenses (in $) in Uruguay in 2002 to that in 2006?
Ensure brevity in your answer.  1.39. What is the ratio of the Expenses (in $) in Congo (Republic) in 2002 to that in 2007?
Keep it short and to the point. 0.01. What is the ratio of the Expenses (in $) in Poland in 2002 to that in 2007?
Provide a succinct answer. 0.52. What is the ratio of the Expenses (in $) in St. Kitts and Nevis in 2002 to that in 2007?
Keep it short and to the point. 0.61. What is the ratio of the Expenses (in $) in Uruguay in 2002 to that in 2007?
Your response must be concise. 3.77. What is the ratio of the Expenses (in $) of Congo (Republic) in 2003 to that in 2004?
Give a very brief answer. 0.37. What is the ratio of the Expenses (in $) of Poland in 2003 to that in 2004?
Your answer should be compact. 0.82. What is the ratio of the Expenses (in $) in St. Kitts and Nevis in 2003 to that in 2004?
Your answer should be compact. 1.02. What is the ratio of the Expenses (in $) of Uruguay in 2003 to that in 2004?
Make the answer very short. 1.65. What is the ratio of the Expenses (in $) of Congo (Republic) in 2003 to that in 2005?
Provide a short and direct response. 0.3. What is the ratio of the Expenses (in $) of Poland in 2003 to that in 2005?
Your answer should be very brief. 0.71. What is the ratio of the Expenses (in $) in St. Kitts and Nevis in 2003 to that in 2005?
Your answer should be compact. 1.04. What is the ratio of the Expenses (in $) in Uruguay in 2003 to that in 2005?
Offer a terse response. 2.9. What is the ratio of the Expenses (in $) in Congo (Republic) in 2003 to that in 2006?
Offer a terse response. 0.22. What is the ratio of the Expenses (in $) in Poland in 2003 to that in 2006?
Give a very brief answer. 0.61. What is the ratio of the Expenses (in $) of St. Kitts and Nevis in 2003 to that in 2006?
Provide a short and direct response. 0.6. What is the ratio of the Expenses (in $) of Uruguay in 2003 to that in 2006?
Your response must be concise. 2.08. What is the ratio of the Expenses (in $) of Congo (Republic) in 2003 to that in 2007?
Offer a terse response. 0.21. What is the ratio of the Expenses (in $) in Poland in 2003 to that in 2007?
Your response must be concise. 0.58. What is the ratio of the Expenses (in $) of St. Kitts and Nevis in 2003 to that in 2007?
Give a very brief answer. 0.7. What is the ratio of the Expenses (in $) in Uruguay in 2003 to that in 2007?
Offer a very short reply. 5.64. What is the ratio of the Expenses (in $) in Congo (Republic) in 2004 to that in 2005?
Offer a very short reply. 0.82. What is the ratio of the Expenses (in $) of Poland in 2004 to that in 2005?
Offer a very short reply. 0.87. What is the ratio of the Expenses (in $) in Uruguay in 2004 to that in 2005?
Your answer should be compact. 1.76. What is the ratio of the Expenses (in $) in Congo (Republic) in 2004 to that in 2006?
Your response must be concise. 0.61. What is the ratio of the Expenses (in $) of Poland in 2004 to that in 2006?
Provide a short and direct response. 0.74. What is the ratio of the Expenses (in $) of St. Kitts and Nevis in 2004 to that in 2006?
Ensure brevity in your answer.  0.59. What is the ratio of the Expenses (in $) in Uruguay in 2004 to that in 2006?
Your response must be concise. 1.26. What is the ratio of the Expenses (in $) in Congo (Republic) in 2004 to that in 2007?
Keep it short and to the point. 0.57. What is the ratio of the Expenses (in $) of Poland in 2004 to that in 2007?
Offer a very short reply. 0.71. What is the ratio of the Expenses (in $) of St. Kitts and Nevis in 2004 to that in 2007?
Ensure brevity in your answer.  0.69. What is the ratio of the Expenses (in $) in Uruguay in 2004 to that in 2007?
Offer a terse response. 3.42. What is the ratio of the Expenses (in $) in Congo (Republic) in 2005 to that in 2006?
Give a very brief answer. 0.74. What is the ratio of the Expenses (in $) in Poland in 2005 to that in 2006?
Provide a succinct answer. 0.85. What is the ratio of the Expenses (in $) of St. Kitts and Nevis in 2005 to that in 2006?
Your answer should be compact. 0.57. What is the ratio of the Expenses (in $) of Uruguay in 2005 to that in 2006?
Keep it short and to the point. 0.72. What is the ratio of the Expenses (in $) of Congo (Republic) in 2005 to that in 2007?
Your answer should be compact. 0.7. What is the ratio of the Expenses (in $) in Poland in 2005 to that in 2007?
Your answer should be compact. 0.81. What is the ratio of the Expenses (in $) of St. Kitts and Nevis in 2005 to that in 2007?
Ensure brevity in your answer.  0.68. What is the ratio of the Expenses (in $) of Uruguay in 2005 to that in 2007?
Provide a short and direct response. 1.95. What is the ratio of the Expenses (in $) in Congo (Republic) in 2006 to that in 2007?
Give a very brief answer. 0.95. What is the ratio of the Expenses (in $) in Poland in 2006 to that in 2007?
Make the answer very short. 0.95. What is the ratio of the Expenses (in $) of St. Kitts and Nevis in 2006 to that in 2007?
Keep it short and to the point. 1.18. What is the ratio of the Expenses (in $) of Uruguay in 2006 to that in 2007?
Keep it short and to the point. 2.71. What is the difference between the highest and the second highest Expenses (in $) of Congo (Republic)?
Offer a terse response. 1.17e+09. What is the difference between the highest and the second highest Expenses (in $) of Poland?
Offer a terse response. 1.49e+08. What is the difference between the highest and the second highest Expenses (in $) of St. Kitts and Nevis?
Ensure brevity in your answer.  1.30e+06. What is the difference between the highest and the second highest Expenses (in $) of Uruguay?
Provide a short and direct response. 3.32e+09. What is the difference between the highest and the lowest Expenses (in $) in Congo (Republic)?
Ensure brevity in your answer.  2.15e+1. What is the difference between the highest and the lowest Expenses (in $) in Poland?
Make the answer very short. 3.06e+09. What is the difference between the highest and the lowest Expenses (in $) in St. Kitts and Nevis?
Keep it short and to the point. 4.30e+06. What is the difference between the highest and the lowest Expenses (in $) in Uruguay?
Your answer should be very brief. 8.24e+09. 